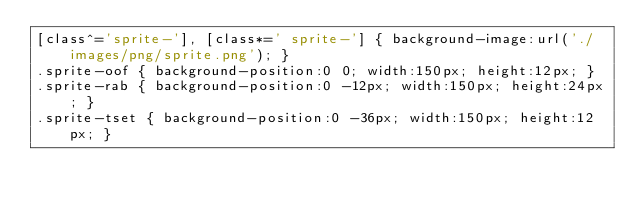<code> <loc_0><loc_0><loc_500><loc_500><_CSS_>[class^='sprite-'], [class*=' sprite-'] { background-image:url('./images/png/sprite.png'); }
.sprite-oof { background-position:0 0; width:150px; height:12px; }
.sprite-rab { background-position:0 -12px; width:150px; height:24px; }
.sprite-tset { background-position:0 -36px; width:150px; height:12px; }
</code> 